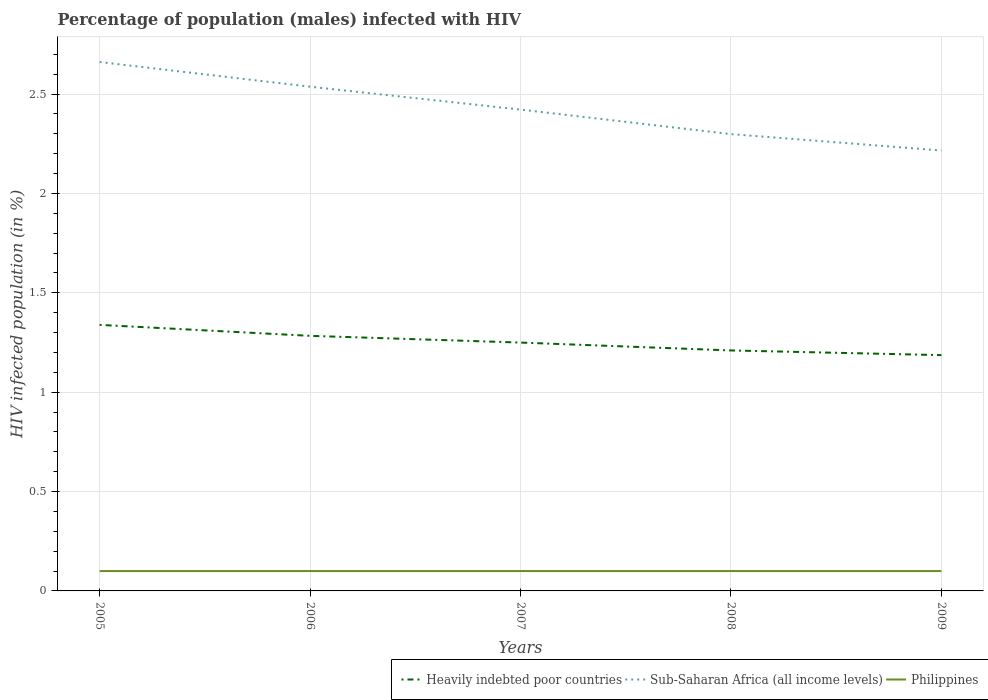Across all years, what is the maximum percentage of HIV infected male population in Sub-Saharan Africa (all income levels)?
Keep it short and to the point. 2.22. What is the difference between the highest and the second highest percentage of HIV infected male population in Sub-Saharan Africa (all income levels)?
Offer a very short reply. 0.45. What is the difference between the highest and the lowest percentage of HIV infected male population in Heavily indebted poor countries?
Offer a very short reply. 2. Is the percentage of HIV infected male population in Philippines strictly greater than the percentage of HIV infected male population in Sub-Saharan Africa (all income levels) over the years?
Make the answer very short. Yes. How many lines are there?
Give a very brief answer. 3. Are the values on the major ticks of Y-axis written in scientific E-notation?
Your answer should be compact. No. Does the graph contain grids?
Ensure brevity in your answer.  Yes. How are the legend labels stacked?
Your answer should be very brief. Horizontal. What is the title of the graph?
Your response must be concise. Percentage of population (males) infected with HIV. What is the label or title of the X-axis?
Your response must be concise. Years. What is the label or title of the Y-axis?
Ensure brevity in your answer.  HIV infected population (in %). What is the HIV infected population (in %) of Heavily indebted poor countries in 2005?
Provide a succinct answer. 1.34. What is the HIV infected population (in %) of Sub-Saharan Africa (all income levels) in 2005?
Offer a very short reply. 2.66. What is the HIV infected population (in %) in Heavily indebted poor countries in 2006?
Make the answer very short. 1.28. What is the HIV infected population (in %) of Sub-Saharan Africa (all income levels) in 2006?
Your answer should be very brief. 2.54. What is the HIV infected population (in %) in Heavily indebted poor countries in 2007?
Give a very brief answer. 1.25. What is the HIV infected population (in %) in Sub-Saharan Africa (all income levels) in 2007?
Provide a short and direct response. 2.42. What is the HIV infected population (in %) in Heavily indebted poor countries in 2008?
Offer a very short reply. 1.21. What is the HIV infected population (in %) in Sub-Saharan Africa (all income levels) in 2008?
Your response must be concise. 2.3. What is the HIV infected population (in %) in Heavily indebted poor countries in 2009?
Provide a short and direct response. 1.19. What is the HIV infected population (in %) in Sub-Saharan Africa (all income levels) in 2009?
Your response must be concise. 2.22. What is the HIV infected population (in %) of Philippines in 2009?
Provide a succinct answer. 0.1. Across all years, what is the maximum HIV infected population (in %) in Heavily indebted poor countries?
Provide a succinct answer. 1.34. Across all years, what is the maximum HIV infected population (in %) of Sub-Saharan Africa (all income levels)?
Your answer should be compact. 2.66. Across all years, what is the minimum HIV infected population (in %) of Heavily indebted poor countries?
Give a very brief answer. 1.19. Across all years, what is the minimum HIV infected population (in %) in Sub-Saharan Africa (all income levels)?
Keep it short and to the point. 2.22. Across all years, what is the minimum HIV infected population (in %) in Philippines?
Provide a succinct answer. 0.1. What is the total HIV infected population (in %) in Heavily indebted poor countries in the graph?
Your answer should be compact. 6.27. What is the total HIV infected population (in %) of Sub-Saharan Africa (all income levels) in the graph?
Make the answer very short. 12.13. What is the total HIV infected population (in %) of Philippines in the graph?
Your answer should be compact. 0.5. What is the difference between the HIV infected population (in %) in Heavily indebted poor countries in 2005 and that in 2006?
Your answer should be compact. 0.06. What is the difference between the HIV infected population (in %) in Sub-Saharan Africa (all income levels) in 2005 and that in 2006?
Your response must be concise. 0.12. What is the difference between the HIV infected population (in %) of Heavily indebted poor countries in 2005 and that in 2007?
Offer a terse response. 0.09. What is the difference between the HIV infected population (in %) of Sub-Saharan Africa (all income levels) in 2005 and that in 2007?
Offer a very short reply. 0.24. What is the difference between the HIV infected population (in %) in Heavily indebted poor countries in 2005 and that in 2008?
Provide a succinct answer. 0.13. What is the difference between the HIV infected population (in %) in Sub-Saharan Africa (all income levels) in 2005 and that in 2008?
Provide a succinct answer. 0.36. What is the difference between the HIV infected population (in %) of Philippines in 2005 and that in 2008?
Offer a very short reply. 0. What is the difference between the HIV infected population (in %) of Heavily indebted poor countries in 2005 and that in 2009?
Ensure brevity in your answer.  0.15. What is the difference between the HIV infected population (in %) in Sub-Saharan Africa (all income levels) in 2005 and that in 2009?
Your answer should be very brief. 0.45. What is the difference between the HIV infected population (in %) in Philippines in 2005 and that in 2009?
Your response must be concise. 0. What is the difference between the HIV infected population (in %) of Heavily indebted poor countries in 2006 and that in 2007?
Offer a very short reply. 0.03. What is the difference between the HIV infected population (in %) of Sub-Saharan Africa (all income levels) in 2006 and that in 2007?
Provide a succinct answer. 0.12. What is the difference between the HIV infected population (in %) in Heavily indebted poor countries in 2006 and that in 2008?
Give a very brief answer. 0.07. What is the difference between the HIV infected population (in %) in Sub-Saharan Africa (all income levels) in 2006 and that in 2008?
Ensure brevity in your answer.  0.24. What is the difference between the HIV infected population (in %) of Philippines in 2006 and that in 2008?
Provide a succinct answer. 0. What is the difference between the HIV infected population (in %) of Heavily indebted poor countries in 2006 and that in 2009?
Offer a terse response. 0.1. What is the difference between the HIV infected population (in %) in Sub-Saharan Africa (all income levels) in 2006 and that in 2009?
Ensure brevity in your answer.  0.32. What is the difference between the HIV infected population (in %) of Philippines in 2006 and that in 2009?
Provide a short and direct response. 0. What is the difference between the HIV infected population (in %) of Heavily indebted poor countries in 2007 and that in 2008?
Make the answer very short. 0.04. What is the difference between the HIV infected population (in %) in Sub-Saharan Africa (all income levels) in 2007 and that in 2008?
Offer a terse response. 0.12. What is the difference between the HIV infected population (in %) of Heavily indebted poor countries in 2007 and that in 2009?
Keep it short and to the point. 0.06. What is the difference between the HIV infected population (in %) of Sub-Saharan Africa (all income levels) in 2007 and that in 2009?
Provide a short and direct response. 0.21. What is the difference between the HIV infected population (in %) of Heavily indebted poor countries in 2008 and that in 2009?
Your response must be concise. 0.02. What is the difference between the HIV infected population (in %) in Sub-Saharan Africa (all income levels) in 2008 and that in 2009?
Your response must be concise. 0.08. What is the difference between the HIV infected population (in %) of Heavily indebted poor countries in 2005 and the HIV infected population (in %) of Sub-Saharan Africa (all income levels) in 2006?
Your answer should be compact. -1.2. What is the difference between the HIV infected population (in %) of Heavily indebted poor countries in 2005 and the HIV infected population (in %) of Philippines in 2006?
Give a very brief answer. 1.24. What is the difference between the HIV infected population (in %) in Sub-Saharan Africa (all income levels) in 2005 and the HIV infected population (in %) in Philippines in 2006?
Offer a terse response. 2.56. What is the difference between the HIV infected population (in %) of Heavily indebted poor countries in 2005 and the HIV infected population (in %) of Sub-Saharan Africa (all income levels) in 2007?
Give a very brief answer. -1.08. What is the difference between the HIV infected population (in %) of Heavily indebted poor countries in 2005 and the HIV infected population (in %) of Philippines in 2007?
Your answer should be very brief. 1.24. What is the difference between the HIV infected population (in %) of Sub-Saharan Africa (all income levels) in 2005 and the HIV infected population (in %) of Philippines in 2007?
Ensure brevity in your answer.  2.56. What is the difference between the HIV infected population (in %) in Heavily indebted poor countries in 2005 and the HIV infected population (in %) in Sub-Saharan Africa (all income levels) in 2008?
Give a very brief answer. -0.96. What is the difference between the HIV infected population (in %) in Heavily indebted poor countries in 2005 and the HIV infected population (in %) in Philippines in 2008?
Provide a short and direct response. 1.24. What is the difference between the HIV infected population (in %) in Sub-Saharan Africa (all income levels) in 2005 and the HIV infected population (in %) in Philippines in 2008?
Offer a very short reply. 2.56. What is the difference between the HIV infected population (in %) in Heavily indebted poor countries in 2005 and the HIV infected population (in %) in Sub-Saharan Africa (all income levels) in 2009?
Give a very brief answer. -0.88. What is the difference between the HIV infected population (in %) in Heavily indebted poor countries in 2005 and the HIV infected population (in %) in Philippines in 2009?
Offer a very short reply. 1.24. What is the difference between the HIV infected population (in %) in Sub-Saharan Africa (all income levels) in 2005 and the HIV infected population (in %) in Philippines in 2009?
Give a very brief answer. 2.56. What is the difference between the HIV infected population (in %) of Heavily indebted poor countries in 2006 and the HIV infected population (in %) of Sub-Saharan Africa (all income levels) in 2007?
Provide a succinct answer. -1.14. What is the difference between the HIV infected population (in %) in Heavily indebted poor countries in 2006 and the HIV infected population (in %) in Philippines in 2007?
Ensure brevity in your answer.  1.18. What is the difference between the HIV infected population (in %) of Sub-Saharan Africa (all income levels) in 2006 and the HIV infected population (in %) of Philippines in 2007?
Offer a terse response. 2.44. What is the difference between the HIV infected population (in %) of Heavily indebted poor countries in 2006 and the HIV infected population (in %) of Sub-Saharan Africa (all income levels) in 2008?
Ensure brevity in your answer.  -1.01. What is the difference between the HIV infected population (in %) in Heavily indebted poor countries in 2006 and the HIV infected population (in %) in Philippines in 2008?
Keep it short and to the point. 1.18. What is the difference between the HIV infected population (in %) of Sub-Saharan Africa (all income levels) in 2006 and the HIV infected population (in %) of Philippines in 2008?
Offer a very short reply. 2.44. What is the difference between the HIV infected population (in %) in Heavily indebted poor countries in 2006 and the HIV infected population (in %) in Sub-Saharan Africa (all income levels) in 2009?
Your answer should be compact. -0.93. What is the difference between the HIV infected population (in %) in Heavily indebted poor countries in 2006 and the HIV infected population (in %) in Philippines in 2009?
Ensure brevity in your answer.  1.18. What is the difference between the HIV infected population (in %) in Sub-Saharan Africa (all income levels) in 2006 and the HIV infected population (in %) in Philippines in 2009?
Offer a very short reply. 2.44. What is the difference between the HIV infected population (in %) of Heavily indebted poor countries in 2007 and the HIV infected population (in %) of Sub-Saharan Africa (all income levels) in 2008?
Your response must be concise. -1.05. What is the difference between the HIV infected population (in %) of Heavily indebted poor countries in 2007 and the HIV infected population (in %) of Philippines in 2008?
Give a very brief answer. 1.15. What is the difference between the HIV infected population (in %) in Sub-Saharan Africa (all income levels) in 2007 and the HIV infected population (in %) in Philippines in 2008?
Provide a succinct answer. 2.32. What is the difference between the HIV infected population (in %) in Heavily indebted poor countries in 2007 and the HIV infected population (in %) in Sub-Saharan Africa (all income levels) in 2009?
Your answer should be very brief. -0.97. What is the difference between the HIV infected population (in %) in Heavily indebted poor countries in 2007 and the HIV infected population (in %) in Philippines in 2009?
Give a very brief answer. 1.15. What is the difference between the HIV infected population (in %) in Sub-Saharan Africa (all income levels) in 2007 and the HIV infected population (in %) in Philippines in 2009?
Keep it short and to the point. 2.32. What is the difference between the HIV infected population (in %) of Heavily indebted poor countries in 2008 and the HIV infected population (in %) of Sub-Saharan Africa (all income levels) in 2009?
Your answer should be compact. -1.01. What is the difference between the HIV infected population (in %) in Heavily indebted poor countries in 2008 and the HIV infected population (in %) in Philippines in 2009?
Offer a terse response. 1.11. What is the difference between the HIV infected population (in %) of Sub-Saharan Africa (all income levels) in 2008 and the HIV infected population (in %) of Philippines in 2009?
Your answer should be very brief. 2.2. What is the average HIV infected population (in %) in Heavily indebted poor countries per year?
Your response must be concise. 1.25. What is the average HIV infected population (in %) of Sub-Saharan Africa (all income levels) per year?
Give a very brief answer. 2.43. In the year 2005, what is the difference between the HIV infected population (in %) in Heavily indebted poor countries and HIV infected population (in %) in Sub-Saharan Africa (all income levels)?
Give a very brief answer. -1.32. In the year 2005, what is the difference between the HIV infected population (in %) in Heavily indebted poor countries and HIV infected population (in %) in Philippines?
Provide a short and direct response. 1.24. In the year 2005, what is the difference between the HIV infected population (in %) of Sub-Saharan Africa (all income levels) and HIV infected population (in %) of Philippines?
Give a very brief answer. 2.56. In the year 2006, what is the difference between the HIV infected population (in %) of Heavily indebted poor countries and HIV infected population (in %) of Sub-Saharan Africa (all income levels)?
Provide a short and direct response. -1.25. In the year 2006, what is the difference between the HIV infected population (in %) of Heavily indebted poor countries and HIV infected population (in %) of Philippines?
Keep it short and to the point. 1.18. In the year 2006, what is the difference between the HIV infected population (in %) of Sub-Saharan Africa (all income levels) and HIV infected population (in %) of Philippines?
Offer a terse response. 2.44. In the year 2007, what is the difference between the HIV infected population (in %) of Heavily indebted poor countries and HIV infected population (in %) of Sub-Saharan Africa (all income levels)?
Make the answer very short. -1.17. In the year 2007, what is the difference between the HIV infected population (in %) of Heavily indebted poor countries and HIV infected population (in %) of Philippines?
Give a very brief answer. 1.15. In the year 2007, what is the difference between the HIV infected population (in %) in Sub-Saharan Africa (all income levels) and HIV infected population (in %) in Philippines?
Give a very brief answer. 2.32. In the year 2008, what is the difference between the HIV infected population (in %) of Heavily indebted poor countries and HIV infected population (in %) of Sub-Saharan Africa (all income levels)?
Provide a succinct answer. -1.09. In the year 2008, what is the difference between the HIV infected population (in %) of Heavily indebted poor countries and HIV infected population (in %) of Philippines?
Your answer should be very brief. 1.11. In the year 2008, what is the difference between the HIV infected population (in %) of Sub-Saharan Africa (all income levels) and HIV infected population (in %) of Philippines?
Offer a terse response. 2.2. In the year 2009, what is the difference between the HIV infected population (in %) of Heavily indebted poor countries and HIV infected population (in %) of Sub-Saharan Africa (all income levels)?
Provide a succinct answer. -1.03. In the year 2009, what is the difference between the HIV infected population (in %) of Heavily indebted poor countries and HIV infected population (in %) of Philippines?
Ensure brevity in your answer.  1.09. In the year 2009, what is the difference between the HIV infected population (in %) of Sub-Saharan Africa (all income levels) and HIV infected population (in %) of Philippines?
Your answer should be very brief. 2.12. What is the ratio of the HIV infected population (in %) of Heavily indebted poor countries in 2005 to that in 2006?
Ensure brevity in your answer.  1.04. What is the ratio of the HIV infected population (in %) of Sub-Saharan Africa (all income levels) in 2005 to that in 2006?
Ensure brevity in your answer.  1.05. What is the ratio of the HIV infected population (in %) of Philippines in 2005 to that in 2006?
Provide a succinct answer. 1. What is the ratio of the HIV infected population (in %) in Heavily indebted poor countries in 2005 to that in 2007?
Provide a succinct answer. 1.07. What is the ratio of the HIV infected population (in %) of Sub-Saharan Africa (all income levels) in 2005 to that in 2007?
Give a very brief answer. 1.1. What is the ratio of the HIV infected population (in %) of Heavily indebted poor countries in 2005 to that in 2008?
Your answer should be compact. 1.11. What is the ratio of the HIV infected population (in %) in Sub-Saharan Africa (all income levels) in 2005 to that in 2008?
Offer a terse response. 1.16. What is the ratio of the HIV infected population (in %) in Philippines in 2005 to that in 2008?
Make the answer very short. 1. What is the ratio of the HIV infected population (in %) of Heavily indebted poor countries in 2005 to that in 2009?
Your response must be concise. 1.13. What is the ratio of the HIV infected population (in %) in Sub-Saharan Africa (all income levels) in 2005 to that in 2009?
Provide a short and direct response. 1.2. What is the ratio of the HIV infected population (in %) of Heavily indebted poor countries in 2006 to that in 2007?
Provide a succinct answer. 1.03. What is the ratio of the HIV infected population (in %) of Sub-Saharan Africa (all income levels) in 2006 to that in 2007?
Your response must be concise. 1.05. What is the ratio of the HIV infected population (in %) in Heavily indebted poor countries in 2006 to that in 2008?
Your response must be concise. 1.06. What is the ratio of the HIV infected population (in %) in Sub-Saharan Africa (all income levels) in 2006 to that in 2008?
Ensure brevity in your answer.  1.1. What is the ratio of the HIV infected population (in %) of Philippines in 2006 to that in 2008?
Provide a short and direct response. 1. What is the ratio of the HIV infected population (in %) in Heavily indebted poor countries in 2006 to that in 2009?
Your answer should be very brief. 1.08. What is the ratio of the HIV infected population (in %) in Sub-Saharan Africa (all income levels) in 2006 to that in 2009?
Offer a very short reply. 1.14. What is the ratio of the HIV infected population (in %) in Philippines in 2006 to that in 2009?
Your answer should be very brief. 1. What is the ratio of the HIV infected population (in %) in Heavily indebted poor countries in 2007 to that in 2008?
Give a very brief answer. 1.03. What is the ratio of the HIV infected population (in %) of Sub-Saharan Africa (all income levels) in 2007 to that in 2008?
Provide a succinct answer. 1.05. What is the ratio of the HIV infected population (in %) of Heavily indebted poor countries in 2007 to that in 2009?
Keep it short and to the point. 1.05. What is the ratio of the HIV infected population (in %) in Sub-Saharan Africa (all income levels) in 2007 to that in 2009?
Provide a short and direct response. 1.09. What is the ratio of the HIV infected population (in %) of Philippines in 2007 to that in 2009?
Your answer should be very brief. 1. What is the ratio of the HIV infected population (in %) of Heavily indebted poor countries in 2008 to that in 2009?
Provide a succinct answer. 1.02. What is the ratio of the HIV infected population (in %) in Sub-Saharan Africa (all income levels) in 2008 to that in 2009?
Ensure brevity in your answer.  1.04. What is the ratio of the HIV infected population (in %) in Philippines in 2008 to that in 2009?
Your answer should be compact. 1. What is the difference between the highest and the second highest HIV infected population (in %) of Heavily indebted poor countries?
Offer a very short reply. 0.06. What is the difference between the highest and the second highest HIV infected population (in %) of Sub-Saharan Africa (all income levels)?
Your answer should be very brief. 0.12. What is the difference between the highest and the second highest HIV infected population (in %) in Philippines?
Your response must be concise. 0. What is the difference between the highest and the lowest HIV infected population (in %) of Heavily indebted poor countries?
Provide a succinct answer. 0.15. What is the difference between the highest and the lowest HIV infected population (in %) in Sub-Saharan Africa (all income levels)?
Your response must be concise. 0.45. 